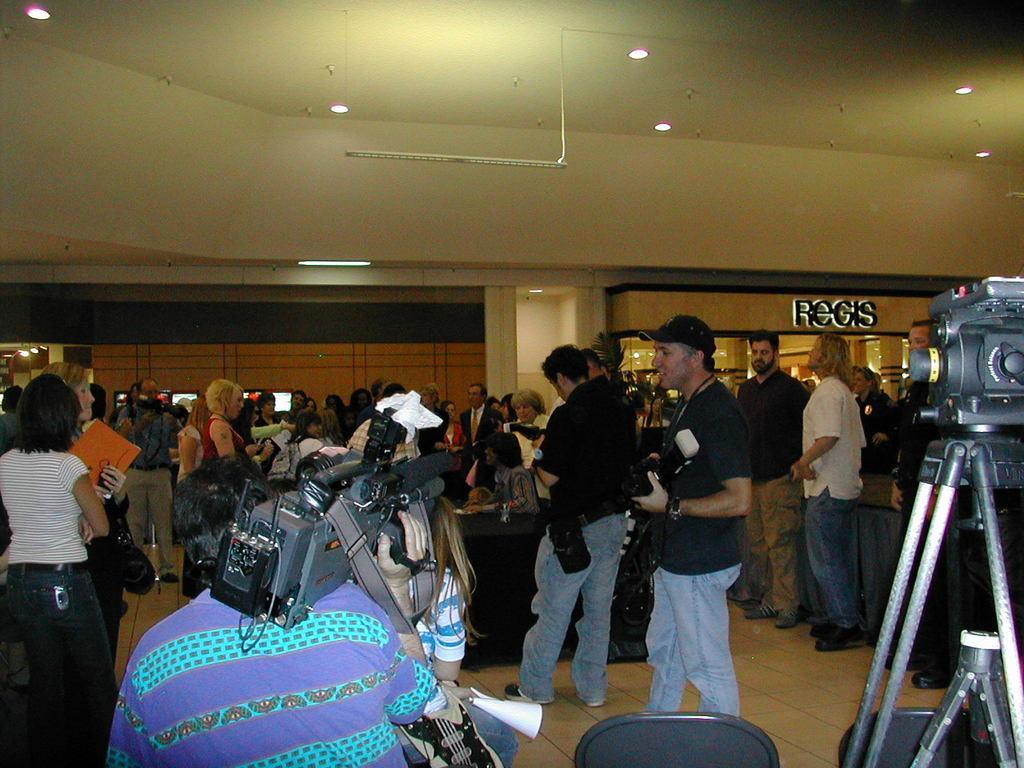How would you summarize this image in a sentence or two? In this image there are group of persons in side a hall few are holding cameras in there hands and few are holding books, on the right side there is a camera, in the background there is a wall, at the top there is a ceiling and lights. 